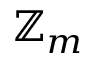Convert formula to latex. <formula><loc_0><loc_0><loc_500><loc_500>\mathbb { Z } _ { m }</formula> 